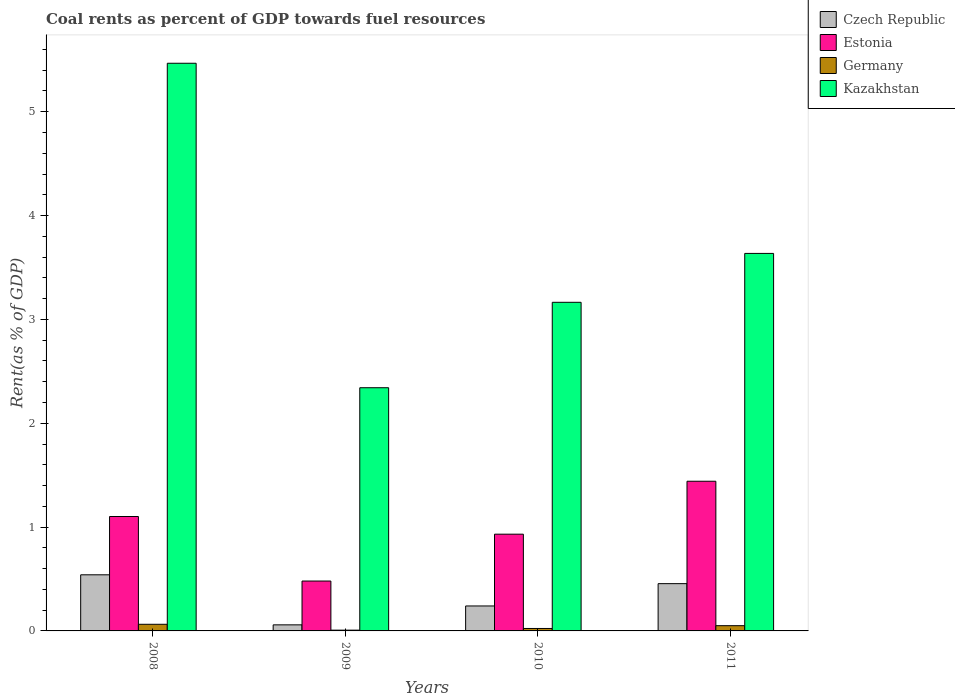How many different coloured bars are there?
Offer a terse response. 4. How many bars are there on the 3rd tick from the left?
Give a very brief answer. 4. What is the label of the 3rd group of bars from the left?
Your response must be concise. 2010. What is the coal rent in Kazakhstan in 2011?
Your answer should be compact. 3.64. Across all years, what is the maximum coal rent in Estonia?
Offer a very short reply. 1.44. Across all years, what is the minimum coal rent in Kazakhstan?
Your answer should be compact. 2.34. In which year was the coal rent in Estonia maximum?
Your answer should be very brief. 2011. In which year was the coal rent in Estonia minimum?
Make the answer very short. 2009. What is the total coal rent in Estonia in the graph?
Give a very brief answer. 3.96. What is the difference between the coal rent in Germany in 2009 and that in 2010?
Provide a short and direct response. -0.02. What is the difference between the coal rent in Germany in 2008 and the coal rent in Czech Republic in 2011?
Keep it short and to the point. -0.39. What is the average coal rent in Czech Republic per year?
Make the answer very short. 0.32. In the year 2008, what is the difference between the coal rent in Estonia and coal rent in Kazakhstan?
Make the answer very short. -4.36. What is the ratio of the coal rent in Kazakhstan in 2008 to that in 2011?
Keep it short and to the point. 1.5. What is the difference between the highest and the second highest coal rent in Czech Republic?
Your response must be concise. 0.09. What is the difference between the highest and the lowest coal rent in Estonia?
Keep it short and to the point. 0.96. In how many years, is the coal rent in Germany greater than the average coal rent in Germany taken over all years?
Offer a terse response. 2. Is the sum of the coal rent in Estonia in 2008 and 2010 greater than the maximum coal rent in Czech Republic across all years?
Ensure brevity in your answer.  Yes. Is it the case that in every year, the sum of the coal rent in Germany and coal rent in Kazakhstan is greater than the sum of coal rent in Czech Republic and coal rent in Estonia?
Your response must be concise. No. What does the 4th bar from the left in 2009 represents?
Make the answer very short. Kazakhstan. What does the 3rd bar from the right in 2008 represents?
Offer a very short reply. Estonia. Are all the bars in the graph horizontal?
Your answer should be very brief. No. What is the difference between two consecutive major ticks on the Y-axis?
Offer a terse response. 1. Does the graph contain any zero values?
Ensure brevity in your answer.  No. Does the graph contain grids?
Your answer should be compact. No. Where does the legend appear in the graph?
Your answer should be very brief. Top right. How are the legend labels stacked?
Give a very brief answer. Vertical. What is the title of the graph?
Offer a very short reply. Coal rents as percent of GDP towards fuel resources. Does "Vanuatu" appear as one of the legend labels in the graph?
Keep it short and to the point. No. What is the label or title of the X-axis?
Give a very brief answer. Years. What is the label or title of the Y-axis?
Your response must be concise. Rent(as % of GDP). What is the Rent(as % of GDP) in Czech Republic in 2008?
Provide a succinct answer. 0.54. What is the Rent(as % of GDP) of Estonia in 2008?
Your answer should be compact. 1.1. What is the Rent(as % of GDP) of Germany in 2008?
Offer a very short reply. 0.06. What is the Rent(as % of GDP) in Kazakhstan in 2008?
Offer a very short reply. 5.47. What is the Rent(as % of GDP) in Czech Republic in 2009?
Keep it short and to the point. 0.06. What is the Rent(as % of GDP) in Estonia in 2009?
Keep it short and to the point. 0.48. What is the Rent(as % of GDP) in Germany in 2009?
Offer a terse response. 0.01. What is the Rent(as % of GDP) of Kazakhstan in 2009?
Offer a terse response. 2.34. What is the Rent(as % of GDP) of Czech Republic in 2010?
Your answer should be very brief. 0.24. What is the Rent(as % of GDP) in Estonia in 2010?
Your response must be concise. 0.93. What is the Rent(as % of GDP) of Germany in 2010?
Provide a short and direct response. 0.02. What is the Rent(as % of GDP) of Kazakhstan in 2010?
Offer a very short reply. 3.16. What is the Rent(as % of GDP) in Czech Republic in 2011?
Your response must be concise. 0.46. What is the Rent(as % of GDP) in Estonia in 2011?
Give a very brief answer. 1.44. What is the Rent(as % of GDP) in Germany in 2011?
Keep it short and to the point. 0.05. What is the Rent(as % of GDP) of Kazakhstan in 2011?
Make the answer very short. 3.64. Across all years, what is the maximum Rent(as % of GDP) in Czech Republic?
Keep it short and to the point. 0.54. Across all years, what is the maximum Rent(as % of GDP) in Estonia?
Your response must be concise. 1.44. Across all years, what is the maximum Rent(as % of GDP) of Germany?
Offer a very short reply. 0.06. Across all years, what is the maximum Rent(as % of GDP) in Kazakhstan?
Offer a terse response. 5.47. Across all years, what is the minimum Rent(as % of GDP) in Czech Republic?
Your answer should be compact. 0.06. Across all years, what is the minimum Rent(as % of GDP) of Estonia?
Your answer should be very brief. 0.48. Across all years, what is the minimum Rent(as % of GDP) in Germany?
Provide a succinct answer. 0.01. Across all years, what is the minimum Rent(as % of GDP) in Kazakhstan?
Provide a short and direct response. 2.34. What is the total Rent(as % of GDP) of Czech Republic in the graph?
Offer a very short reply. 1.29. What is the total Rent(as % of GDP) in Estonia in the graph?
Your response must be concise. 3.96. What is the total Rent(as % of GDP) of Germany in the graph?
Ensure brevity in your answer.  0.15. What is the total Rent(as % of GDP) in Kazakhstan in the graph?
Provide a succinct answer. 14.61. What is the difference between the Rent(as % of GDP) in Czech Republic in 2008 and that in 2009?
Give a very brief answer. 0.48. What is the difference between the Rent(as % of GDP) of Estonia in 2008 and that in 2009?
Provide a succinct answer. 0.62. What is the difference between the Rent(as % of GDP) of Germany in 2008 and that in 2009?
Your answer should be compact. 0.06. What is the difference between the Rent(as % of GDP) of Kazakhstan in 2008 and that in 2009?
Provide a succinct answer. 3.12. What is the difference between the Rent(as % of GDP) in Czech Republic in 2008 and that in 2010?
Offer a terse response. 0.3. What is the difference between the Rent(as % of GDP) of Estonia in 2008 and that in 2010?
Provide a succinct answer. 0.17. What is the difference between the Rent(as % of GDP) of Germany in 2008 and that in 2010?
Provide a short and direct response. 0.04. What is the difference between the Rent(as % of GDP) of Kazakhstan in 2008 and that in 2010?
Provide a succinct answer. 2.3. What is the difference between the Rent(as % of GDP) of Czech Republic in 2008 and that in 2011?
Offer a very short reply. 0.09. What is the difference between the Rent(as % of GDP) in Estonia in 2008 and that in 2011?
Your answer should be compact. -0.34. What is the difference between the Rent(as % of GDP) in Germany in 2008 and that in 2011?
Keep it short and to the point. 0.01. What is the difference between the Rent(as % of GDP) of Kazakhstan in 2008 and that in 2011?
Your response must be concise. 1.83. What is the difference between the Rent(as % of GDP) in Czech Republic in 2009 and that in 2010?
Ensure brevity in your answer.  -0.18. What is the difference between the Rent(as % of GDP) in Estonia in 2009 and that in 2010?
Give a very brief answer. -0.45. What is the difference between the Rent(as % of GDP) of Germany in 2009 and that in 2010?
Your answer should be very brief. -0.02. What is the difference between the Rent(as % of GDP) of Kazakhstan in 2009 and that in 2010?
Your answer should be very brief. -0.82. What is the difference between the Rent(as % of GDP) of Czech Republic in 2009 and that in 2011?
Provide a succinct answer. -0.4. What is the difference between the Rent(as % of GDP) of Estonia in 2009 and that in 2011?
Give a very brief answer. -0.96. What is the difference between the Rent(as % of GDP) in Germany in 2009 and that in 2011?
Give a very brief answer. -0.04. What is the difference between the Rent(as % of GDP) of Kazakhstan in 2009 and that in 2011?
Your answer should be compact. -1.29. What is the difference between the Rent(as % of GDP) of Czech Republic in 2010 and that in 2011?
Give a very brief answer. -0.21. What is the difference between the Rent(as % of GDP) of Estonia in 2010 and that in 2011?
Offer a very short reply. -0.51. What is the difference between the Rent(as % of GDP) of Germany in 2010 and that in 2011?
Ensure brevity in your answer.  -0.03. What is the difference between the Rent(as % of GDP) in Kazakhstan in 2010 and that in 2011?
Your answer should be compact. -0.47. What is the difference between the Rent(as % of GDP) in Czech Republic in 2008 and the Rent(as % of GDP) in Estonia in 2009?
Provide a succinct answer. 0.06. What is the difference between the Rent(as % of GDP) of Czech Republic in 2008 and the Rent(as % of GDP) of Germany in 2009?
Offer a terse response. 0.53. What is the difference between the Rent(as % of GDP) in Czech Republic in 2008 and the Rent(as % of GDP) in Kazakhstan in 2009?
Your answer should be compact. -1.8. What is the difference between the Rent(as % of GDP) of Estonia in 2008 and the Rent(as % of GDP) of Germany in 2009?
Give a very brief answer. 1.09. What is the difference between the Rent(as % of GDP) in Estonia in 2008 and the Rent(as % of GDP) in Kazakhstan in 2009?
Your answer should be very brief. -1.24. What is the difference between the Rent(as % of GDP) in Germany in 2008 and the Rent(as % of GDP) in Kazakhstan in 2009?
Your response must be concise. -2.28. What is the difference between the Rent(as % of GDP) in Czech Republic in 2008 and the Rent(as % of GDP) in Estonia in 2010?
Provide a succinct answer. -0.39. What is the difference between the Rent(as % of GDP) of Czech Republic in 2008 and the Rent(as % of GDP) of Germany in 2010?
Provide a short and direct response. 0.52. What is the difference between the Rent(as % of GDP) in Czech Republic in 2008 and the Rent(as % of GDP) in Kazakhstan in 2010?
Make the answer very short. -2.62. What is the difference between the Rent(as % of GDP) of Estonia in 2008 and the Rent(as % of GDP) of Germany in 2010?
Your answer should be very brief. 1.08. What is the difference between the Rent(as % of GDP) of Estonia in 2008 and the Rent(as % of GDP) of Kazakhstan in 2010?
Your response must be concise. -2.06. What is the difference between the Rent(as % of GDP) of Germany in 2008 and the Rent(as % of GDP) of Kazakhstan in 2010?
Keep it short and to the point. -3.1. What is the difference between the Rent(as % of GDP) of Czech Republic in 2008 and the Rent(as % of GDP) of Estonia in 2011?
Provide a short and direct response. -0.9. What is the difference between the Rent(as % of GDP) of Czech Republic in 2008 and the Rent(as % of GDP) of Germany in 2011?
Make the answer very short. 0.49. What is the difference between the Rent(as % of GDP) in Czech Republic in 2008 and the Rent(as % of GDP) in Kazakhstan in 2011?
Your answer should be compact. -3.1. What is the difference between the Rent(as % of GDP) in Estonia in 2008 and the Rent(as % of GDP) in Germany in 2011?
Offer a very short reply. 1.05. What is the difference between the Rent(as % of GDP) in Estonia in 2008 and the Rent(as % of GDP) in Kazakhstan in 2011?
Your answer should be very brief. -2.53. What is the difference between the Rent(as % of GDP) in Germany in 2008 and the Rent(as % of GDP) in Kazakhstan in 2011?
Give a very brief answer. -3.57. What is the difference between the Rent(as % of GDP) of Czech Republic in 2009 and the Rent(as % of GDP) of Estonia in 2010?
Provide a short and direct response. -0.87. What is the difference between the Rent(as % of GDP) of Czech Republic in 2009 and the Rent(as % of GDP) of Germany in 2010?
Ensure brevity in your answer.  0.03. What is the difference between the Rent(as % of GDP) in Czech Republic in 2009 and the Rent(as % of GDP) in Kazakhstan in 2010?
Keep it short and to the point. -3.11. What is the difference between the Rent(as % of GDP) in Estonia in 2009 and the Rent(as % of GDP) in Germany in 2010?
Provide a succinct answer. 0.46. What is the difference between the Rent(as % of GDP) of Estonia in 2009 and the Rent(as % of GDP) of Kazakhstan in 2010?
Give a very brief answer. -2.68. What is the difference between the Rent(as % of GDP) of Germany in 2009 and the Rent(as % of GDP) of Kazakhstan in 2010?
Give a very brief answer. -3.16. What is the difference between the Rent(as % of GDP) in Czech Republic in 2009 and the Rent(as % of GDP) in Estonia in 2011?
Give a very brief answer. -1.38. What is the difference between the Rent(as % of GDP) in Czech Republic in 2009 and the Rent(as % of GDP) in Germany in 2011?
Your answer should be compact. 0.01. What is the difference between the Rent(as % of GDP) in Czech Republic in 2009 and the Rent(as % of GDP) in Kazakhstan in 2011?
Offer a terse response. -3.58. What is the difference between the Rent(as % of GDP) of Estonia in 2009 and the Rent(as % of GDP) of Germany in 2011?
Keep it short and to the point. 0.43. What is the difference between the Rent(as % of GDP) of Estonia in 2009 and the Rent(as % of GDP) of Kazakhstan in 2011?
Provide a short and direct response. -3.16. What is the difference between the Rent(as % of GDP) of Germany in 2009 and the Rent(as % of GDP) of Kazakhstan in 2011?
Your answer should be compact. -3.63. What is the difference between the Rent(as % of GDP) in Czech Republic in 2010 and the Rent(as % of GDP) in Estonia in 2011?
Ensure brevity in your answer.  -1.2. What is the difference between the Rent(as % of GDP) of Czech Republic in 2010 and the Rent(as % of GDP) of Germany in 2011?
Give a very brief answer. 0.19. What is the difference between the Rent(as % of GDP) of Czech Republic in 2010 and the Rent(as % of GDP) of Kazakhstan in 2011?
Provide a succinct answer. -3.4. What is the difference between the Rent(as % of GDP) in Estonia in 2010 and the Rent(as % of GDP) in Germany in 2011?
Provide a succinct answer. 0.88. What is the difference between the Rent(as % of GDP) of Estonia in 2010 and the Rent(as % of GDP) of Kazakhstan in 2011?
Provide a succinct answer. -2.7. What is the difference between the Rent(as % of GDP) of Germany in 2010 and the Rent(as % of GDP) of Kazakhstan in 2011?
Offer a very short reply. -3.61. What is the average Rent(as % of GDP) in Czech Republic per year?
Your answer should be compact. 0.32. What is the average Rent(as % of GDP) of Estonia per year?
Give a very brief answer. 0.99. What is the average Rent(as % of GDP) in Germany per year?
Keep it short and to the point. 0.04. What is the average Rent(as % of GDP) in Kazakhstan per year?
Provide a short and direct response. 3.65. In the year 2008, what is the difference between the Rent(as % of GDP) in Czech Republic and Rent(as % of GDP) in Estonia?
Your response must be concise. -0.56. In the year 2008, what is the difference between the Rent(as % of GDP) in Czech Republic and Rent(as % of GDP) in Germany?
Give a very brief answer. 0.48. In the year 2008, what is the difference between the Rent(as % of GDP) of Czech Republic and Rent(as % of GDP) of Kazakhstan?
Offer a terse response. -4.93. In the year 2008, what is the difference between the Rent(as % of GDP) of Estonia and Rent(as % of GDP) of Germany?
Offer a very short reply. 1.04. In the year 2008, what is the difference between the Rent(as % of GDP) in Estonia and Rent(as % of GDP) in Kazakhstan?
Provide a short and direct response. -4.36. In the year 2008, what is the difference between the Rent(as % of GDP) in Germany and Rent(as % of GDP) in Kazakhstan?
Ensure brevity in your answer.  -5.4. In the year 2009, what is the difference between the Rent(as % of GDP) of Czech Republic and Rent(as % of GDP) of Estonia?
Provide a short and direct response. -0.42. In the year 2009, what is the difference between the Rent(as % of GDP) in Czech Republic and Rent(as % of GDP) in Germany?
Ensure brevity in your answer.  0.05. In the year 2009, what is the difference between the Rent(as % of GDP) in Czech Republic and Rent(as % of GDP) in Kazakhstan?
Give a very brief answer. -2.28. In the year 2009, what is the difference between the Rent(as % of GDP) of Estonia and Rent(as % of GDP) of Germany?
Keep it short and to the point. 0.47. In the year 2009, what is the difference between the Rent(as % of GDP) in Estonia and Rent(as % of GDP) in Kazakhstan?
Offer a terse response. -1.86. In the year 2009, what is the difference between the Rent(as % of GDP) in Germany and Rent(as % of GDP) in Kazakhstan?
Give a very brief answer. -2.33. In the year 2010, what is the difference between the Rent(as % of GDP) in Czech Republic and Rent(as % of GDP) in Estonia?
Your answer should be very brief. -0.69. In the year 2010, what is the difference between the Rent(as % of GDP) in Czech Republic and Rent(as % of GDP) in Germany?
Provide a succinct answer. 0.22. In the year 2010, what is the difference between the Rent(as % of GDP) of Czech Republic and Rent(as % of GDP) of Kazakhstan?
Your answer should be compact. -2.92. In the year 2010, what is the difference between the Rent(as % of GDP) in Estonia and Rent(as % of GDP) in Germany?
Ensure brevity in your answer.  0.91. In the year 2010, what is the difference between the Rent(as % of GDP) in Estonia and Rent(as % of GDP) in Kazakhstan?
Provide a succinct answer. -2.23. In the year 2010, what is the difference between the Rent(as % of GDP) in Germany and Rent(as % of GDP) in Kazakhstan?
Offer a very short reply. -3.14. In the year 2011, what is the difference between the Rent(as % of GDP) of Czech Republic and Rent(as % of GDP) of Estonia?
Provide a short and direct response. -0.99. In the year 2011, what is the difference between the Rent(as % of GDP) in Czech Republic and Rent(as % of GDP) in Germany?
Give a very brief answer. 0.4. In the year 2011, what is the difference between the Rent(as % of GDP) of Czech Republic and Rent(as % of GDP) of Kazakhstan?
Offer a very short reply. -3.18. In the year 2011, what is the difference between the Rent(as % of GDP) in Estonia and Rent(as % of GDP) in Germany?
Keep it short and to the point. 1.39. In the year 2011, what is the difference between the Rent(as % of GDP) of Estonia and Rent(as % of GDP) of Kazakhstan?
Your answer should be compact. -2.19. In the year 2011, what is the difference between the Rent(as % of GDP) in Germany and Rent(as % of GDP) in Kazakhstan?
Provide a succinct answer. -3.58. What is the ratio of the Rent(as % of GDP) in Czech Republic in 2008 to that in 2009?
Offer a terse response. 9.24. What is the ratio of the Rent(as % of GDP) of Estonia in 2008 to that in 2009?
Your answer should be compact. 2.29. What is the ratio of the Rent(as % of GDP) in Germany in 2008 to that in 2009?
Offer a very short reply. 8.58. What is the ratio of the Rent(as % of GDP) in Kazakhstan in 2008 to that in 2009?
Make the answer very short. 2.33. What is the ratio of the Rent(as % of GDP) in Czech Republic in 2008 to that in 2010?
Keep it short and to the point. 2.25. What is the ratio of the Rent(as % of GDP) in Estonia in 2008 to that in 2010?
Ensure brevity in your answer.  1.18. What is the ratio of the Rent(as % of GDP) of Germany in 2008 to that in 2010?
Provide a succinct answer. 2.71. What is the ratio of the Rent(as % of GDP) in Kazakhstan in 2008 to that in 2010?
Provide a short and direct response. 1.73. What is the ratio of the Rent(as % of GDP) in Czech Republic in 2008 to that in 2011?
Give a very brief answer. 1.19. What is the ratio of the Rent(as % of GDP) of Estonia in 2008 to that in 2011?
Offer a very short reply. 0.76. What is the ratio of the Rent(as % of GDP) of Germany in 2008 to that in 2011?
Make the answer very short. 1.26. What is the ratio of the Rent(as % of GDP) of Kazakhstan in 2008 to that in 2011?
Give a very brief answer. 1.5. What is the ratio of the Rent(as % of GDP) in Czech Republic in 2009 to that in 2010?
Provide a succinct answer. 0.24. What is the ratio of the Rent(as % of GDP) in Estonia in 2009 to that in 2010?
Ensure brevity in your answer.  0.52. What is the ratio of the Rent(as % of GDP) in Germany in 2009 to that in 2010?
Provide a succinct answer. 0.32. What is the ratio of the Rent(as % of GDP) in Kazakhstan in 2009 to that in 2010?
Make the answer very short. 0.74. What is the ratio of the Rent(as % of GDP) in Czech Republic in 2009 to that in 2011?
Ensure brevity in your answer.  0.13. What is the ratio of the Rent(as % of GDP) in Germany in 2009 to that in 2011?
Your response must be concise. 0.15. What is the ratio of the Rent(as % of GDP) of Kazakhstan in 2009 to that in 2011?
Keep it short and to the point. 0.64. What is the ratio of the Rent(as % of GDP) in Czech Republic in 2010 to that in 2011?
Give a very brief answer. 0.53. What is the ratio of the Rent(as % of GDP) in Estonia in 2010 to that in 2011?
Offer a terse response. 0.65. What is the ratio of the Rent(as % of GDP) of Germany in 2010 to that in 2011?
Give a very brief answer. 0.47. What is the ratio of the Rent(as % of GDP) of Kazakhstan in 2010 to that in 2011?
Offer a very short reply. 0.87. What is the difference between the highest and the second highest Rent(as % of GDP) in Czech Republic?
Make the answer very short. 0.09. What is the difference between the highest and the second highest Rent(as % of GDP) in Estonia?
Keep it short and to the point. 0.34. What is the difference between the highest and the second highest Rent(as % of GDP) in Germany?
Your answer should be very brief. 0.01. What is the difference between the highest and the second highest Rent(as % of GDP) in Kazakhstan?
Offer a terse response. 1.83. What is the difference between the highest and the lowest Rent(as % of GDP) of Czech Republic?
Your answer should be very brief. 0.48. What is the difference between the highest and the lowest Rent(as % of GDP) of Germany?
Your response must be concise. 0.06. What is the difference between the highest and the lowest Rent(as % of GDP) in Kazakhstan?
Your answer should be compact. 3.12. 